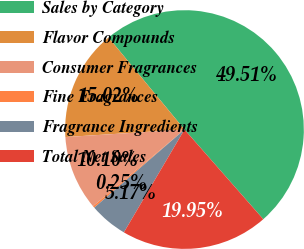<chart> <loc_0><loc_0><loc_500><loc_500><pie_chart><fcel>Sales by Category<fcel>Flavor Compounds<fcel>Consumer Fragrances<fcel>Fine Fragrances<fcel>Fragrance Ingredients<fcel>Total Net Sales<nl><fcel>49.51%<fcel>15.02%<fcel>10.1%<fcel>0.25%<fcel>5.17%<fcel>19.95%<nl></chart> 